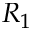<formula> <loc_0><loc_0><loc_500><loc_500>R _ { 1 }</formula> 